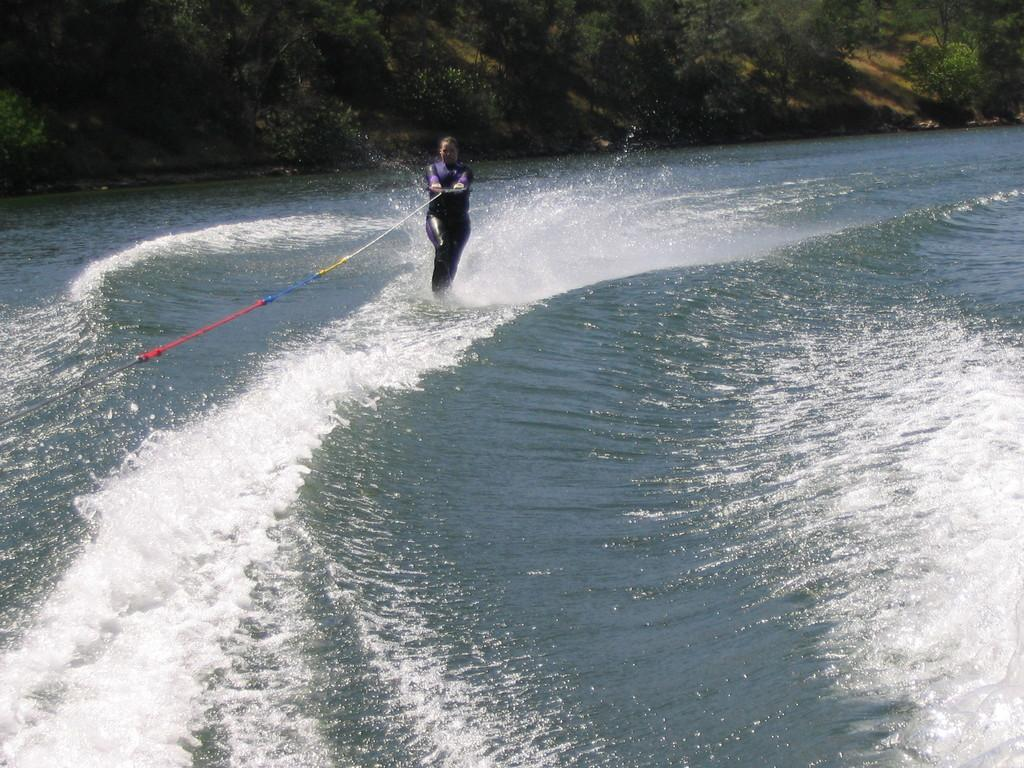What activity is the person in the image engaged in? The person is wakeboarding in the image. Where is the person performing this activity? The person is on the water. What can be seen in the background of the image? There are trees in the background of the image. What type of straw is being used to stir the stew in the image? There is no stew or straw present in the image; it features a person wakeboarding on the water with trees in the background. 